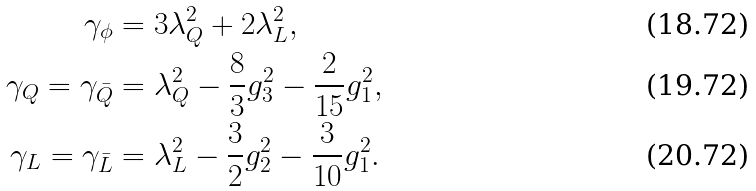<formula> <loc_0><loc_0><loc_500><loc_500>\gamma _ { \phi } & = 3 \lambda _ { Q } ^ { 2 } + 2 \lambda _ { L } ^ { 2 } , \\ \gamma _ { Q } = \gamma _ { \bar { Q } } & = \lambda _ { Q } ^ { 2 } - \frac { 8 } { 3 } g _ { 3 } ^ { 2 } - \frac { 2 } { 1 5 } g _ { 1 } ^ { 2 } , \\ \gamma _ { L } = \gamma _ { \bar { L } } & = \lambda _ { L } ^ { 2 } - \frac { 3 } { 2 } g _ { 2 } ^ { 2 } - \frac { 3 } { 1 0 } g _ { 1 } ^ { 2 } .</formula> 